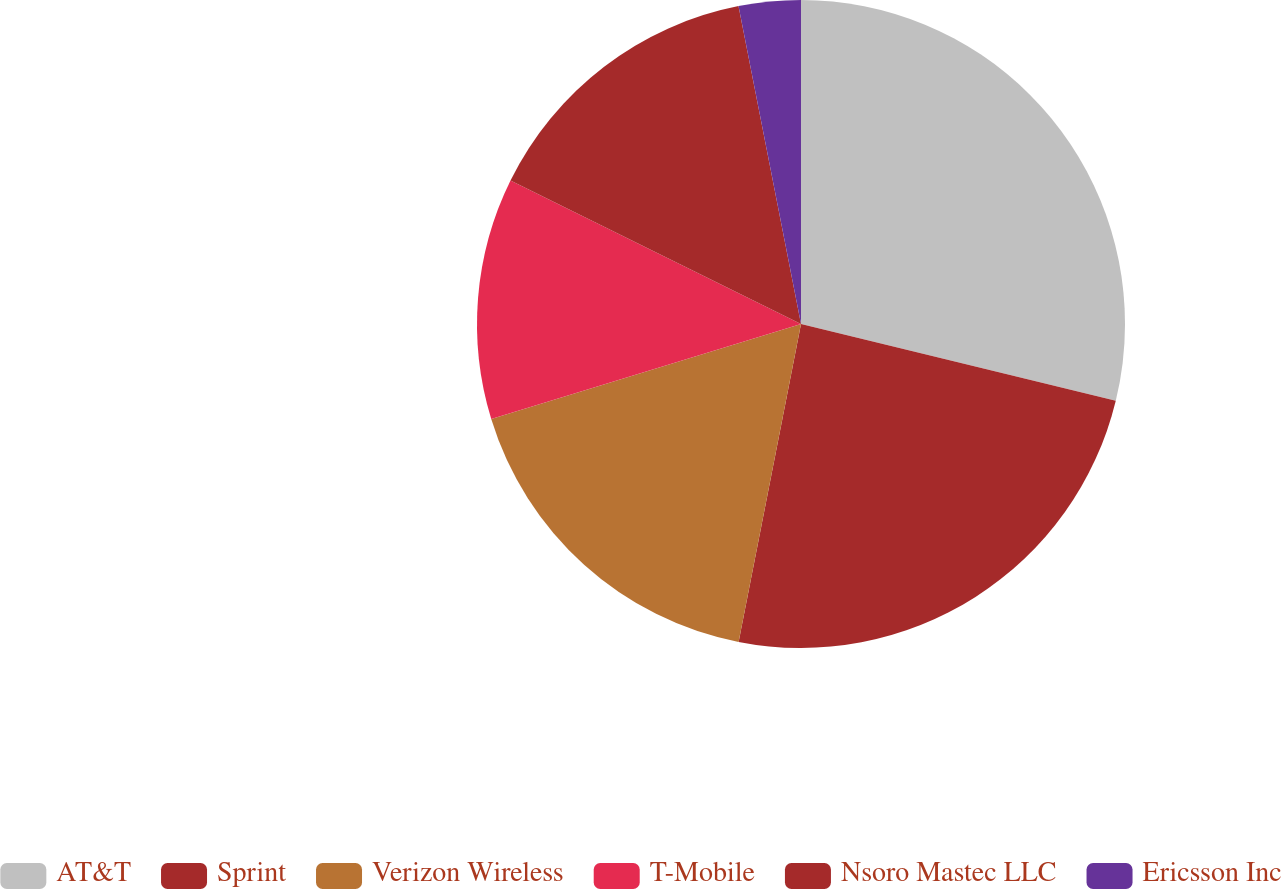Convert chart. <chart><loc_0><loc_0><loc_500><loc_500><pie_chart><fcel>AT&T<fcel>Sprint<fcel>Verizon Wireless<fcel>T-Mobile<fcel>Nsoro Mastec LLC<fcel>Ericsson Inc<nl><fcel>28.81%<fcel>24.28%<fcel>17.18%<fcel>12.04%<fcel>14.61%<fcel>3.09%<nl></chart> 